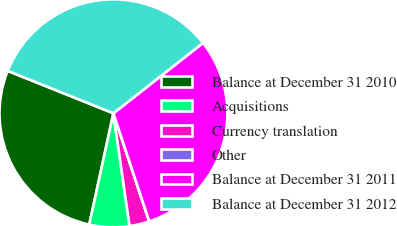Convert chart to OTSL. <chart><loc_0><loc_0><loc_500><loc_500><pie_chart><fcel>Balance at December 31 2010<fcel>Acquisitions<fcel>Currency translation<fcel>Other<fcel>Balance at December 31 2011<fcel>Balance at December 31 2012<nl><fcel>27.67%<fcel>5.66%<fcel>2.83%<fcel>0.01%<fcel>30.5%<fcel>33.33%<nl></chart> 